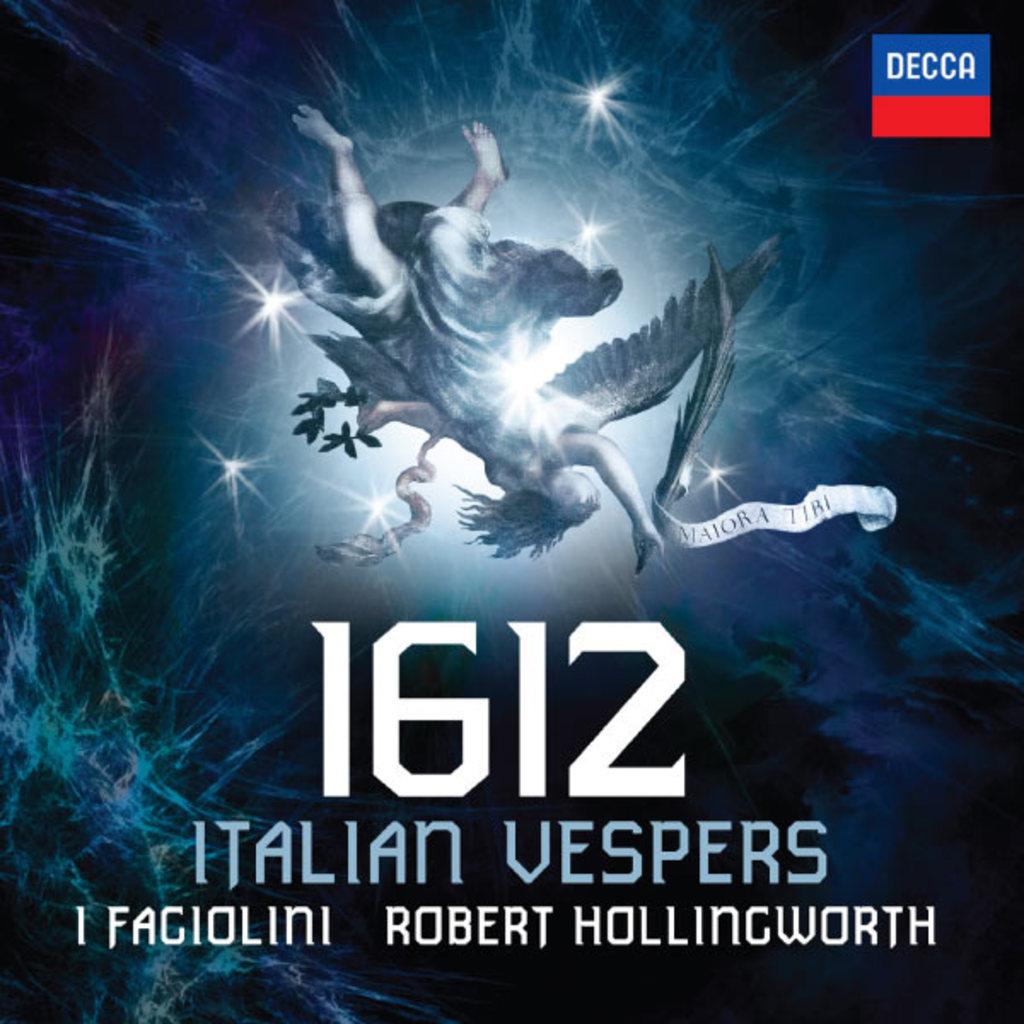What year is shown?
Make the answer very short. 1612. What is the title of this?
Your answer should be very brief. 1612. 